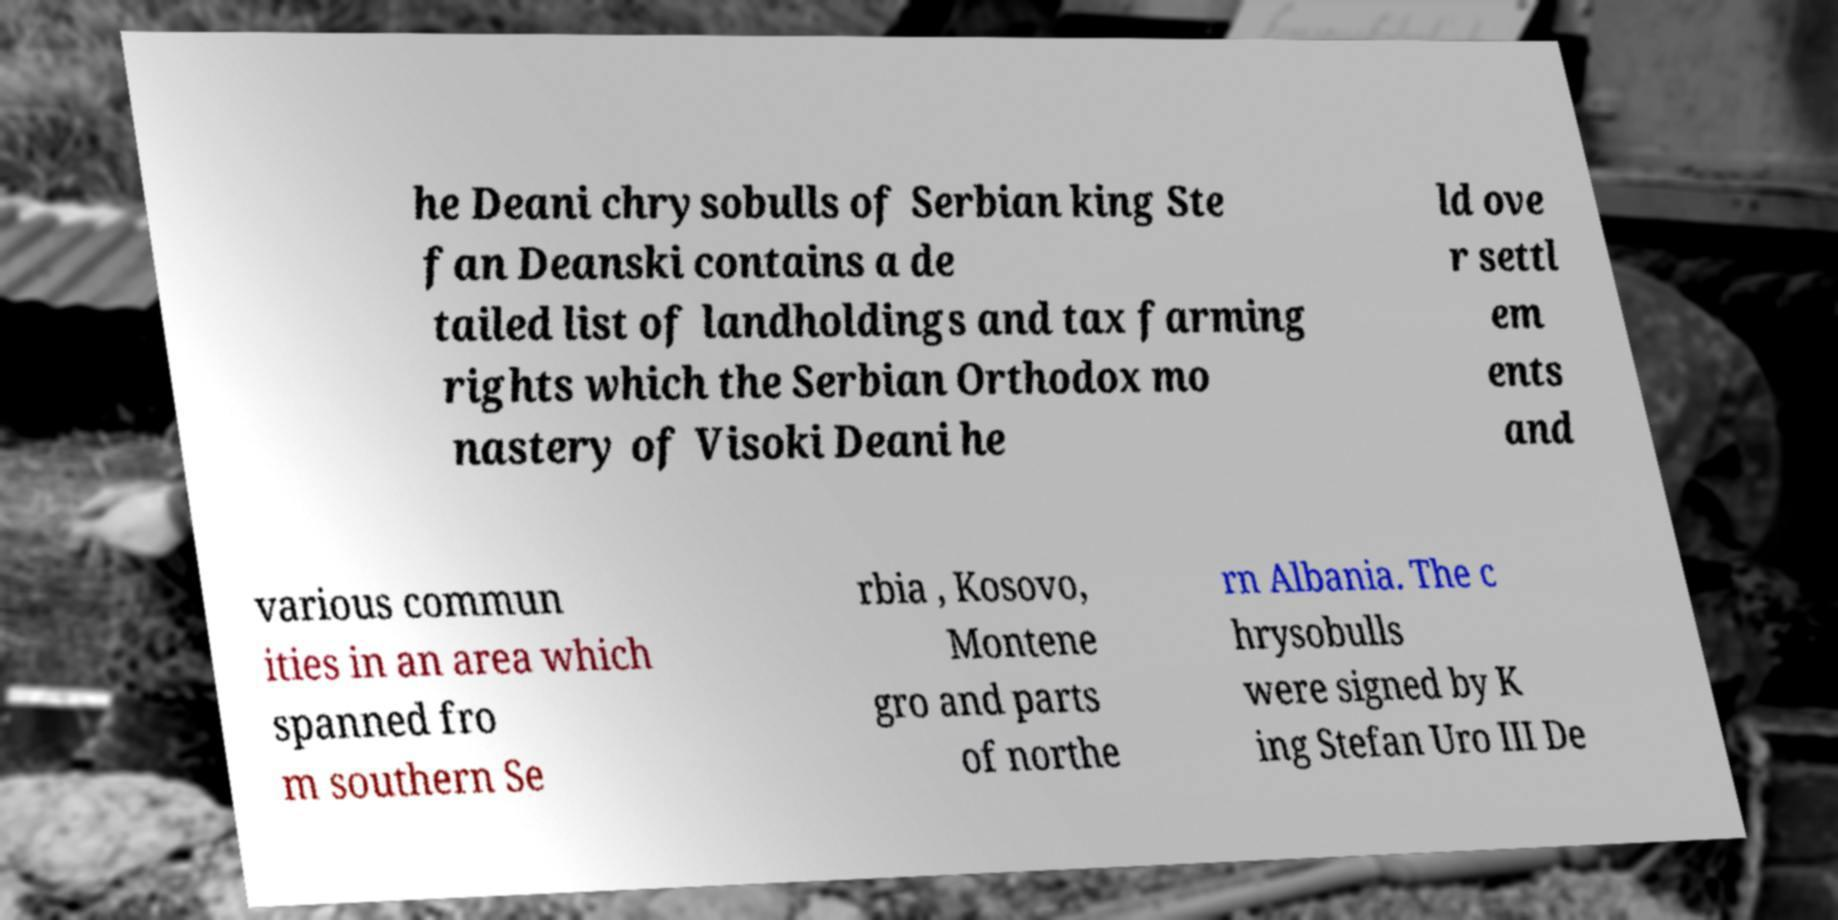I need the written content from this picture converted into text. Can you do that? he Deani chrysobulls of Serbian king Ste fan Deanski contains a de tailed list of landholdings and tax farming rights which the Serbian Orthodox mo nastery of Visoki Deani he ld ove r settl em ents and various commun ities in an area which spanned fro m southern Se rbia , Kosovo, Montene gro and parts of northe rn Albania. The c hrysobulls were signed by K ing Stefan Uro III De 